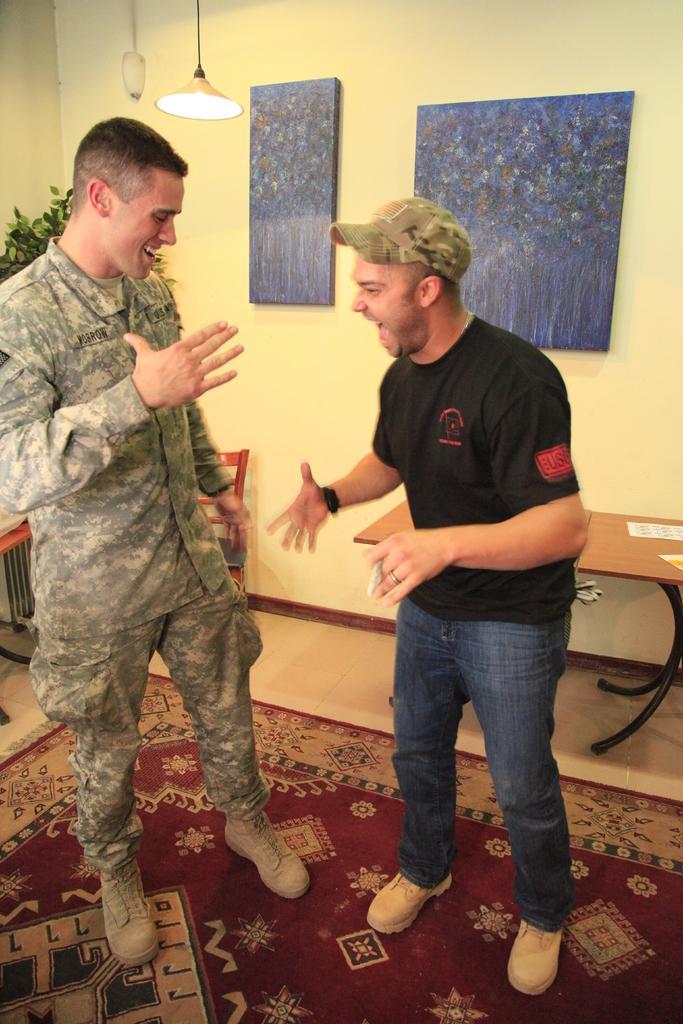In one or two sentences, can you explain what this image depicts? In this image the two persons are standing on the floor and behind the there are tables,chairs,posters and lights are there and the background is yellow. 